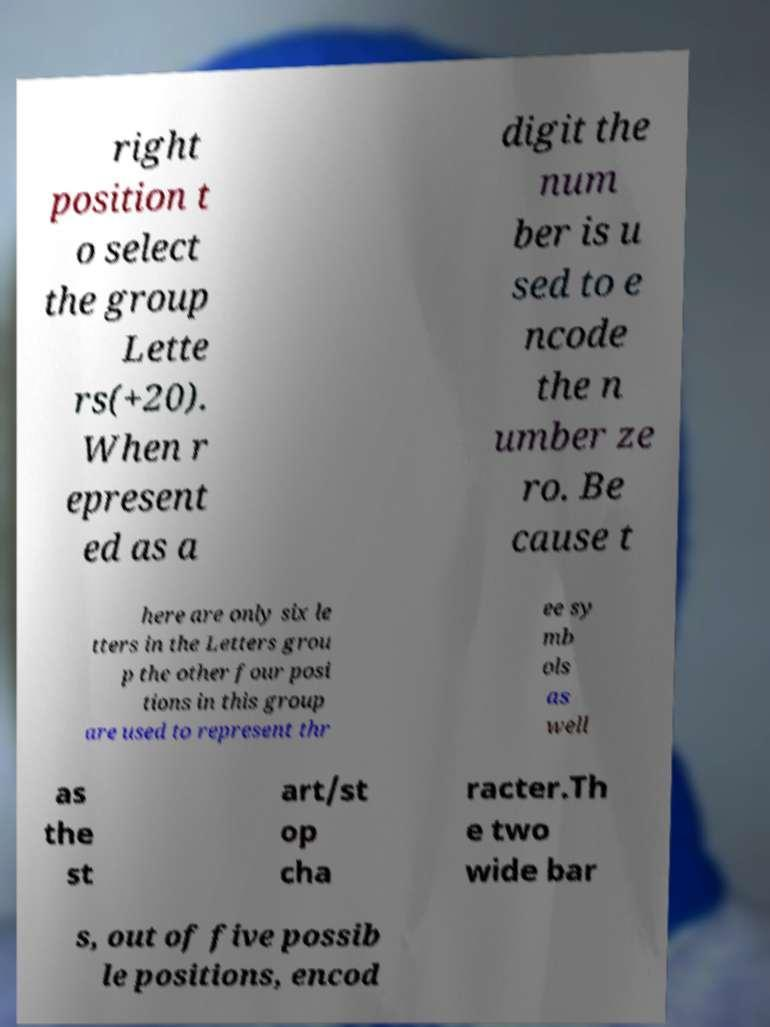Can you accurately transcribe the text from the provided image for me? right position t o select the group Lette rs(+20). When r epresent ed as a digit the num ber is u sed to e ncode the n umber ze ro. Be cause t here are only six le tters in the Letters grou p the other four posi tions in this group are used to represent thr ee sy mb ols as well as the st art/st op cha racter.Th e two wide bar s, out of five possib le positions, encod 